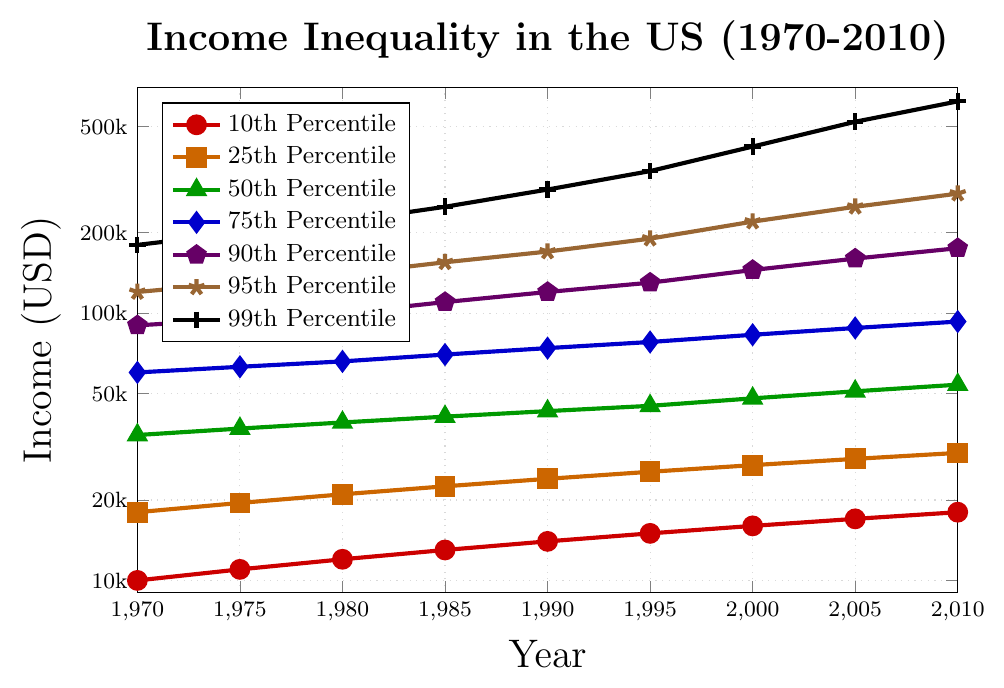What is the income of the 10th percentile in 1970 and 2010? Check the red line (10th percentile) in the figure for the income values in 1970 and 2010. In 1970, it is 10,000 while in 2010, it is 18,000.
Answer: 10,000 and 18,000 Between which years did the top 1% (99th Percentile) see the most significant growth in income? Examine the black line (99th percentile). The rise appears steepest between 1995 and 2000, where it jumps from 340,000 to 420,000, indicating a 80,000 increase.
Answer: 1995 to 2000 How much more did the 95th percentile earn compared to the 10th percentile in 2010? Look at the income for the 95th (280,000) and 10th (18,000) percentiles in 2010. The difference is 280,000 - 18,000 = 262,000.
Answer: 262,000 Which percentile showed the smallest increase in income from 1970 to 2010? Calculate the differences for all percentiles from 2010 to 1970 and compare them. The 10th percentile increase is 18,000 - 10,000 = 8,000. This is the smallest increase.
Answer: 10th Percentile In which decade did the 50th percentile (median) cross the 50,000 USD mark? Trace the green line (50th percentile) to find the year when it first exceeds 50,000. It happens in the 2000-2010 decade.
Answer: 2000-2010 Compare the incomes of the 25th and 75th percentiles in 1980. Which is greater and by how much? Examine the orange and blue lines in 1980. The 25th percentile is 21,000, and the 75th percentile is 66,000. The difference is 66,000 - 21,000 = 45,000.
Answer: 75th; 45,000 How did the income disparity between the 10th and 90th percentiles change from 1980 to 2010? Calculate the differences for both years. In 1980: 100,000 - 12,000 = 88,000 and in 2010: 175,000 - 18,000 = 157,000, indicating an increase in disparity by 157,000 - 88,000 = 69,000.
Answer: Increased by 69,000 What is the ratio of the income of the 99th percentile to the 50th percentile in 2000? Find the incomes for the 99th (420,000) and 50th (48,000) percentiles in 2000. The ratio is 420,000 / 48,000 ≈ 8.75.
Answer: 8.75 Did the income more than double for the 90th percentile from 1970 to 2010? Check the violet line. In 1970, it's 90,000 and in 2010 it's 175,000. Since 2*90,000 = 180,000 > 175,000, the income did not double.
Answer: No What is the visual difference in trends for income growth between the 75th and 95th percentiles? Look at the blue (75th) and brown (95th) lines. Both have upward trends but the growth for the 95th percentile accelerates more sharply, especially post-1985.
Answer: 95th percentile grows faster 